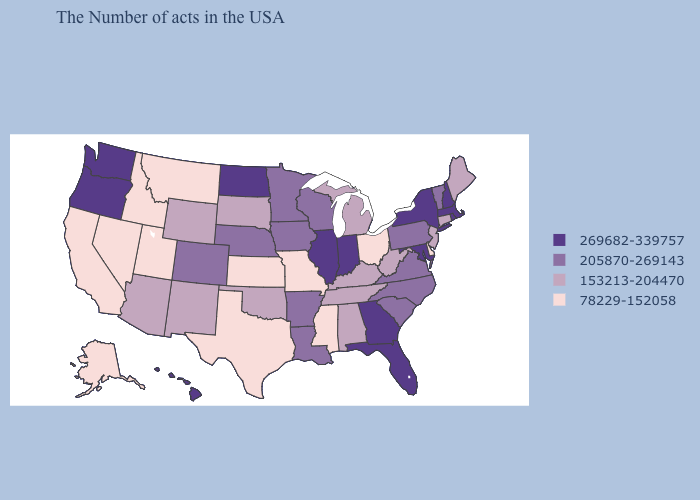Name the states that have a value in the range 269682-339757?
Short answer required. Massachusetts, Rhode Island, New Hampshire, New York, Maryland, Florida, Georgia, Indiana, Illinois, North Dakota, Washington, Oregon, Hawaii. Among the states that border Washington , does Idaho have the lowest value?
Answer briefly. Yes. Name the states that have a value in the range 78229-152058?
Concise answer only. Delaware, Ohio, Mississippi, Missouri, Kansas, Texas, Utah, Montana, Idaho, Nevada, California, Alaska. What is the value of Idaho?
Give a very brief answer. 78229-152058. Name the states that have a value in the range 78229-152058?
Be succinct. Delaware, Ohio, Mississippi, Missouri, Kansas, Texas, Utah, Montana, Idaho, Nevada, California, Alaska. Does Virginia have the same value as Mississippi?
Keep it brief. No. Which states hav the highest value in the Northeast?
Quick response, please. Massachusetts, Rhode Island, New Hampshire, New York. Name the states that have a value in the range 153213-204470?
Give a very brief answer. Maine, Connecticut, New Jersey, West Virginia, Michigan, Kentucky, Alabama, Tennessee, Oklahoma, South Dakota, Wyoming, New Mexico, Arizona. What is the value of Wisconsin?
Give a very brief answer. 205870-269143. Does the first symbol in the legend represent the smallest category?
Write a very short answer. No. Does the map have missing data?
Quick response, please. No. What is the value of Oklahoma?
Concise answer only. 153213-204470. Which states have the lowest value in the USA?
Write a very short answer. Delaware, Ohio, Mississippi, Missouri, Kansas, Texas, Utah, Montana, Idaho, Nevada, California, Alaska. Among the states that border South Carolina , which have the lowest value?
Write a very short answer. North Carolina. Does Vermont have the same value as New Mexico?
Answer briefly. No. 